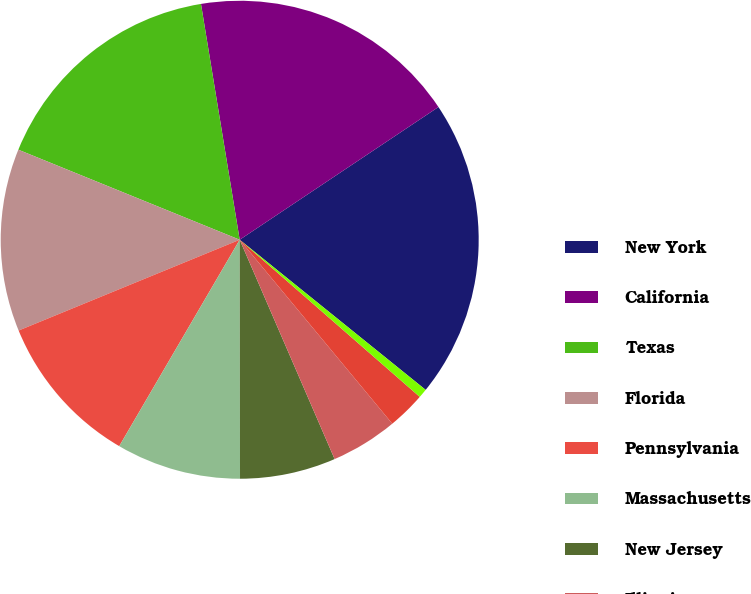<chart> <loc_0><loc_0><loc_500><loc_500><pie_chart><fcel>New York<fcel>California<fcel>Texas<fcel>Florida<fcel>Pennsylvania<fcel>Massachusetts<fcel>New Jersey<fcel>Illinois<fcel>Georgia<fcel>Virginia<nl><fcel>20.18%<fcel>18.22%<fcel>16.26%<fcel>12.35%<fcel>10.39%<fcel>8.43%<fcel>6.48%<fcel>4.52%<fcel>2.56%<fcel>0.61%<nl></chart> 